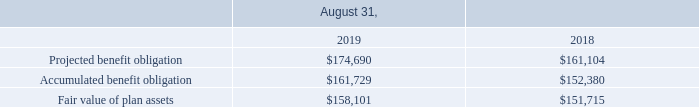Accumulated Benefit Obligation
The following table provides information for the plans with an accumulated benefit obligation for fiscal years 2019 and 2018 (in thousands):
What was the fair value of plan assets in 2019?
Answer scale should be: thousand. $158,101. Which years does the table provide information for the plans with an accumulated benefit obligation for? 2019, 2018. What was the Accumulated benefit obligation in 2018?
Answer scale should be: thousand. $152,380. What was the change in Accumulated benefit obligation between 2018 and 2019?
Answer scale should be: thousand. $161,729-$152,380
Answer: 9349. How many years did the Projected benefit obligation exceed $150,000 thousand? 2019##2018
Answer: 2. What was the percentage change in the fair value of plan assets between 2018 and 2019?
Answer scale should be: percent. ($158,101-$151,715)/$151,715
Answer: 4.21. 